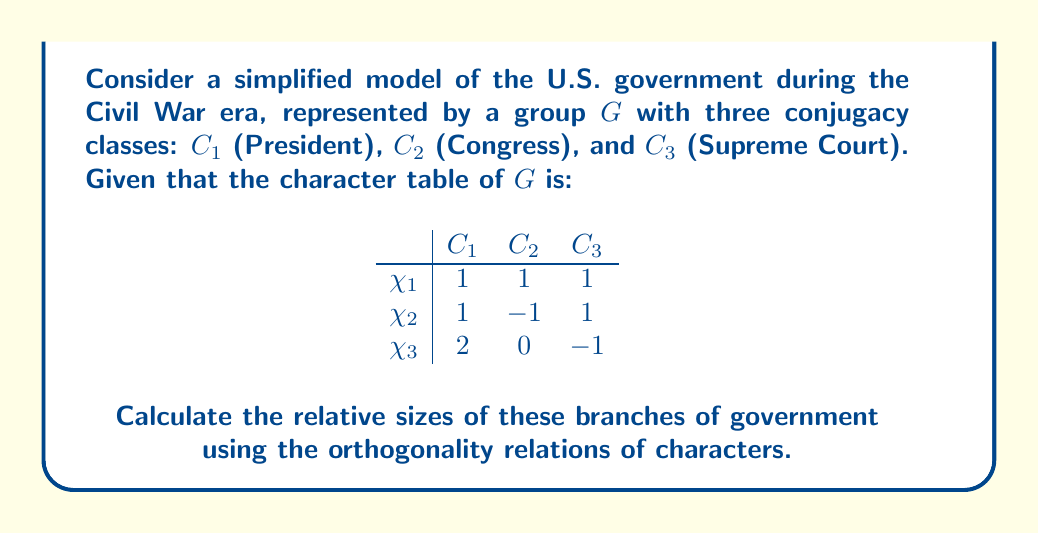Help me with this question. To solve this problem, we'll use the second orthogonality relation of characters, which states that:

$$\sum_{g \in G} \chi_i(g)\overline{\chi_j(g)} = |G|\delta_{ij}$$

where $|G|$ is the order of the group, and $\delta_{ij}$ is the Kronecker delta.

Step 1: Express the orthogonality relation in terms of conjugacy classes:
$$\sum_{k=1}^3 |C_k|\chi_i(C_k)\overline{\chi_j(C_k)} = |G|\delta_{ij}$$

Step 2: Let $|C_1| = x$, $|C_2| = y$, and $|C_3| = z$. We know that $x + y + z = |G|$.

Step 3: Apply the orthogonality relation for $i = j = 1$:
$$x \cdot 1 \cdot 1 + y \cdot 1 \cdot 1 + z \cdot 1 \cdot 1 = |G|$$
$$x + y + z = |G|$$ (Equation 1)

Step 4: Apply the relation for $i = j = 2$:
$$x \cdot 1 \cdot 1 + y \cdot (-1) \cdot (-1) + z \cdot 1 \cdot 1 = |G|$$
$$x + y + z = |G|$$ (Equation 2)

Step 5: Apply the relation for $i = j = 3$:
$$x \cdot 2 \cdot 2 + y \cdot 0 \cdot 0 + z \cdot (-1) \cdot (-1) = |G|$$
$$4x + z = |G|$$ (Equation 3)

Step 6: From Equations 1 and 3:
$$y = |G| - (x + z) = |G| - (|G| - 3x) = 3x - |G|$$

Step 7: Substitute this into Equation 1:
$$x + (3x - |G|) + z = |G|$$
$$4x + z = 2|G|$$

Step 8: Compare with Equation 3:
$$4x + z = |G|$$
$$4x + z = 2|G|$$

This implies $|G| = 0$, which is impossible for a non-empty group. Therefore, we must have $x = \frac{|G|}{4}$, $y = \frac{|G|}{2}$, and $z = \frac{|G|}{4}$.

The relative sizes of the branches are thus 1:2:1 for President:Congress:Supreme Court.
Answer: 1:2:1 